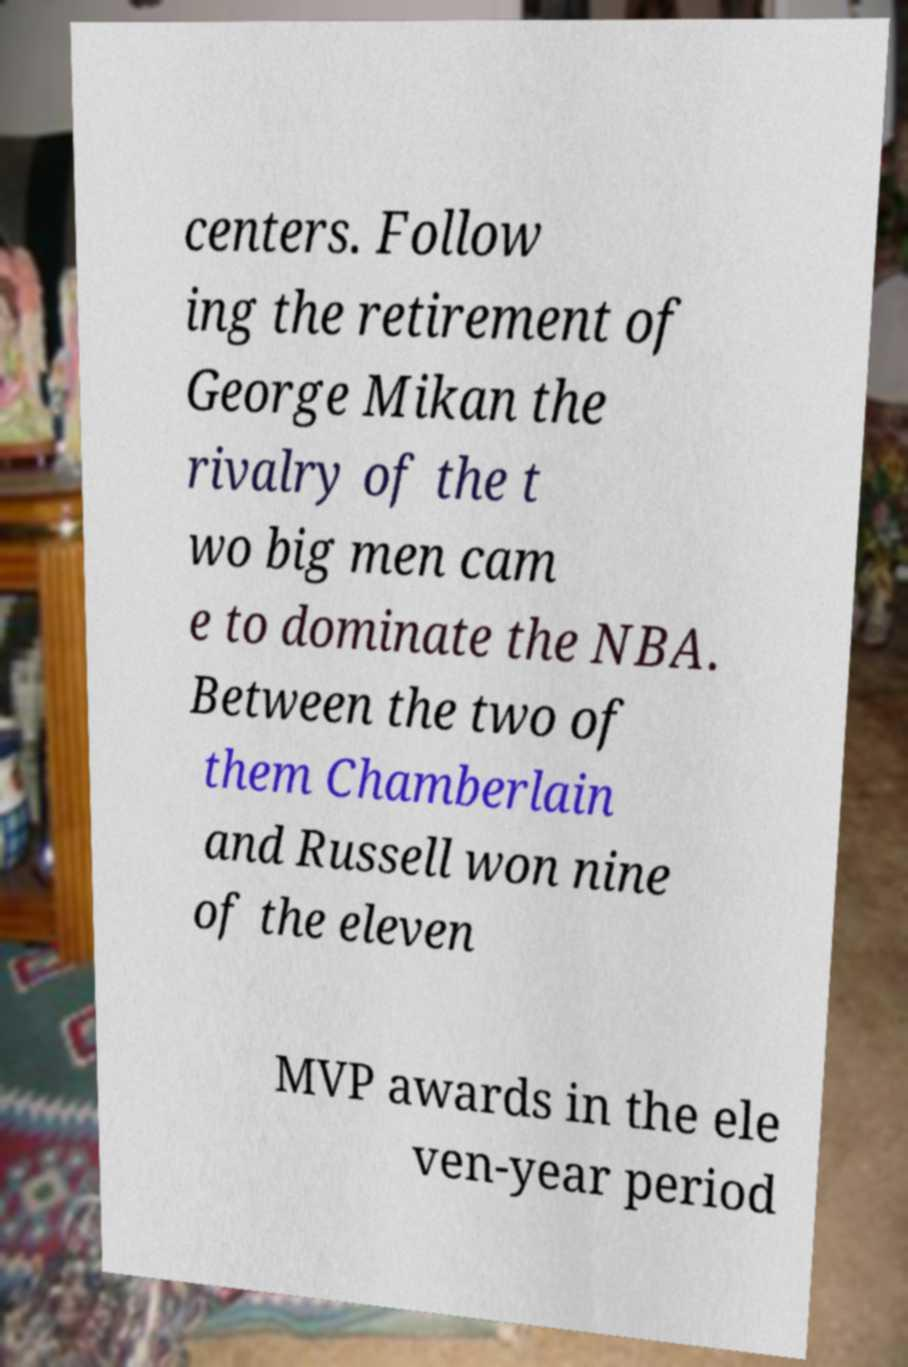Can you accurately transcribe the text from the provided image for me? centers. Follow ing the retirement of George Mikan the rivalry of the t wo big men cam e to dominate the NBA. Between the two of them Chamberlain and Russell won nine of the eleven MVP awards in the ele ven-year period 